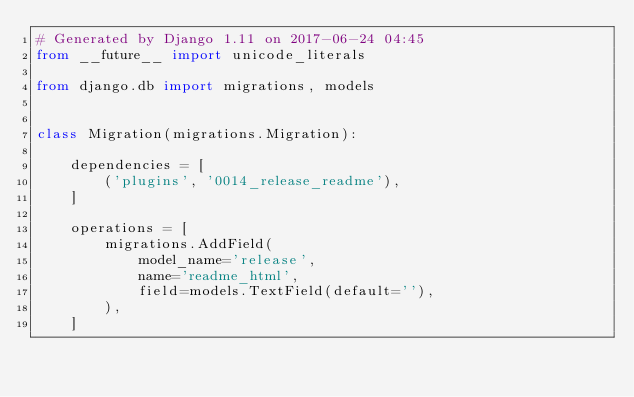<code> <loc_0><loc_0><loc_500><loc_500><_Python_># Generated by Django 1.11 on 2017-06-24 04:45
from __future__ import unicode_literals

from django.db import migrations, models


class Migration(migrations.Migration):

    dependencies = [
        ('plugins', '0014_release_readme'),
    ]

    operations = [
        migrations.AddField(
            model_name='release',
            name='readme_html',
            field=models.TextField(default=''),
        ),
    ]
</code> 